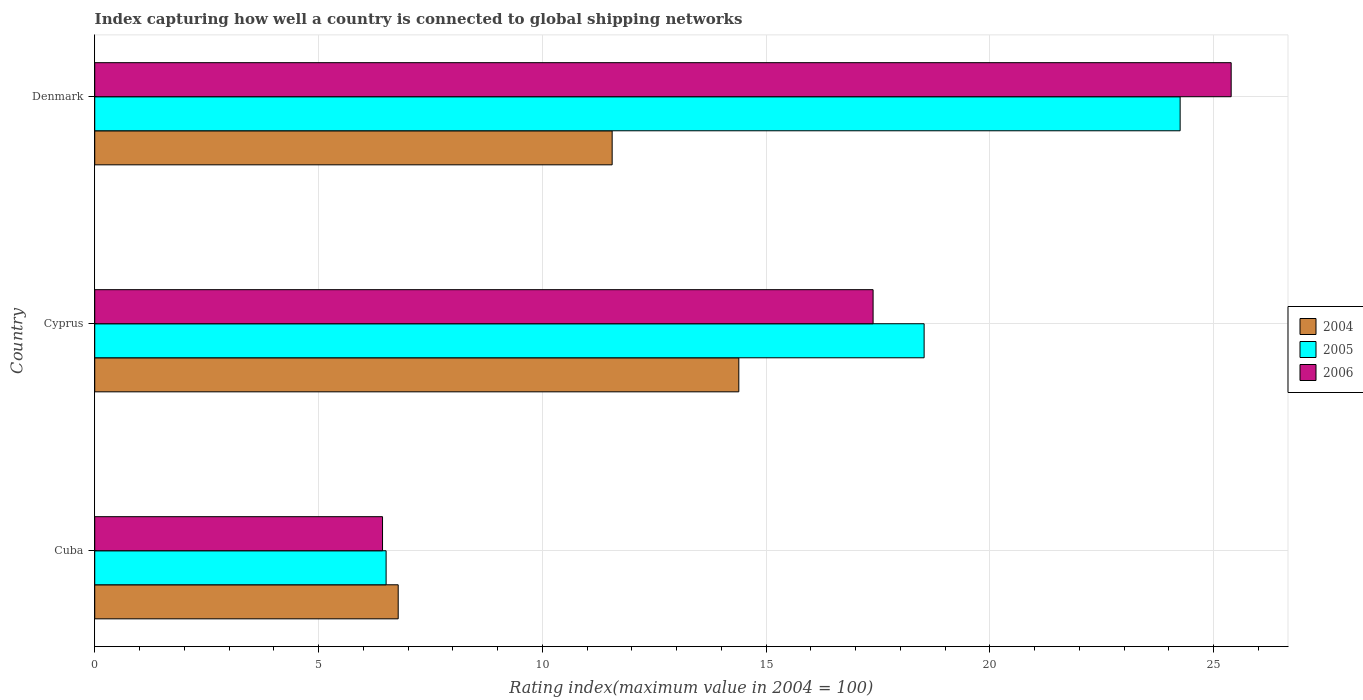Are the number of bars on each tick of the Y-axis equal?
Give a very brief answer. Yes. What is the label of the 3rd group of bars from the top?
Make the answer very short. Cuba. What is the rating index in 2006 in Cuba?
Provide a short and direct response. 6.43. Across all countries, what is the maximum rating index in 2004?
Offer a very short reply. 14.39. Across all countries, what is the minimum rating index in 2006?
Provide a succinct answer. 6.43. In which country was the rating index in 2004 maximum?
Make the answer very short. Cyprus. In which country was the rating index in 2005 minimum?
Offer a terse response. Cuba. What is the total rating index in 2004 in the graph?
Keep it short and to the point. 32.73. What is the difference between the rating index in 2005 in Cuba and that in Cyprus?
Offer a very short reply. -12.02. What is the difference between the rating index in 2006 in Cuba and the rating index in 2005 in Cyprus?
Offer a very short reply. -12.1. What is the average rating index in 2006 per country?
Keep it short and to the point. 16.4. What is the difference between the rating index in 2005 and rating index in 2006 in Denmark?
Ensure brevity in your answer.  -1.14. In how many countries, is the rating index in 2005 greater than 7 ?
Make the answer very short. 2. What is the ratio of the rating index in 2005 in Cuba to that in Cyprus?
Offer a very short reply. 0.35. What is the difference between the highest and the second highest rating index in 2006?
Your response must be concise. 8. What is the difference between the highest and the lowest rating index in 2006?
Provide a succinct answer. 18.96. Is the sum of the rating index in 2005 in Cyprus and Denmark greater than the maximum rating index in 2004 across all countries?
Your answer should be compact. Yes. Are all the bars in the graph horizontal?
Ensure brevity in your answer.  Yes. How many countries are there in the graph?
Keep it short and to the point. 3. Are the values on the major ticks of X-axis written in scientific E-notation?
Keep it short and to the point. No. Does the graph contain any zero values?
Your answer should be very brief. No. Does the graph contain grids?
Give a very brief answer. Yes. How are the legend labels stacked?
Provide a short and direct response. Vertical. What is the title of the graph?
Keep it short and to the point. Index capturing how well a country is connected to global shipping networks. What is the label or title of the X-axis?
Keep it short and to the point. Rating index(maximum value in 2004 = 100). What is the label or title of the Y-axis?
Provide a short and direct response. Country. What is the Rating index(maximum value in 2004 = 100) in 2004 in Cuba?
Ensure brevity in your answer.  6.78. What is the Rating index(maximum value in 2004 = 100) in 2005 in Cuba?
Provide a short and direct response. 6.51. What is the Rating index(maximum value in 2004 = 100) in 2006 in Cuba?
Offer a very short reply. 6.43. What is the Rating index(maximum value in 2004 = 100) of 2004 in Cyprus?
Your answer should be very brief. 14.39. What is the Rating index(maximum value in 2004 = 100) of 2005 in Cyprus?
Keep it short and to the point. 18.53. What is the Rating index(maximum value in 2004 = 100) in 2006 in Cyprus?
Your answer should be compact. 17.39. What is the Rating index(maximum value in 2004 = 100) of 2004 in Denmark?
Provide a short and direct response. 11.56. What is the Rating index(maximum value in 2004 = 100) of 2005 in Denmark?
Keep it short and to the point. 24.25. What is the Rating index(maximum value in 2004 = 100) in 2006 in Denmark?
Make the answer very short. 25.39. Across all countries, what is the maximum Rating index(maximum value in 2004 = 100) of 2004?
Offer a terse response. 14.39. Across all countries, what is the maximum Rating index(maximum value in 2004 = 100) in 2005?
Your answer should be compact. 24.25. Across all countries, what is the maximum Rating index(maximum value in 2004 = 100) of 2006?
Your answer should be compact. 25.39. Across all countries, what is the minimum Rating index(maximum value in 2004 = 100) in 2004?
Offer a very short reply. 6.78. Across all countries, what is the minimum Rating index(maximum value in 2004 = 100) in 2005?
Your response must be concise. 6.51. Across all countries, what is the minimum Rating index(maximum value in 2004 = 100) of 2006?
Your response must be concise. 6.43. What is the total Rating index(maximum value in 2004 = 100) of 2004 in the graph?
Provide a short and direct response. 32.73. What is the total Rating index(maximum value in 2004 = 100) in 2005 in the graph?
Keep it short and to the point. 49.29. What is the total Rating index(maximum value in 2004 = 100) in 2006 in the graph?
Your answer should be compact. 49.21. What is the difference between the Rating index(maximum value in 2004 = 100) in 2004 in Cuba and that in Cyprus?
Ensure brevity in your answer.  -7.61. What is the difference between the Rating index(maximum value in 2004 = 100) of 2005 in Cuba and that in Cyprus?
Offer a terse response. -12.02. What is the difference between the Rating index(maximum value in 2004 = 100) in 2006 in Cuba and that in Cyprus?
Your response must be concise. -10.96. What is the difference between the Rating index(maximum value in 2004 = 100) in 2004 in Cuba and that in Denmark?
Keep it short and to the point. -4.78. What is the difference between the Rating index(maximum value in 2004 = 100) in 2005 in Cuba and that in Denmark?
Your answer should be compact. -17.74. What is the difference between the Rating index(maximum value in 2004 = 100) in 2006 in Cuba and that in Denmark?
Your response must be concise. -18.96. What is the difference between the Rating index(maximum value in 2004 = 100) in 2004 in Cyprus and that in Denmark?
Your answer should be compact. 2.83. What is the difference between the Rating index(maximum value in 2004 = 100) of 2005 in Cyprus and that in Denmark?
Your answer should be very brief. -5.72. What is the difference between the Rating index(maximum value in 2004 = 100) in 2004 in Cuba and the Rating index(maximum value in 2004 = 100) in 2005 in Cyprus?
Offer a terse response. -11.75. What is the difference between the Rating index(maximum value in 2004 = 100) in 2004 in Cuba and the Rating index(maximum value in 2004 = 100) in 2006 in Cyprus?
Keep it short and to the point. -10.61. What is the difference between the Rating index(maximum value in 2004 = 100) in 2005 in Cuba and the Rating index(maximum value in 2004 = 100) in 2006 in Cyprus?
Your answer should be very brief. -10.88. What is the difference between the Rating index(maximum value in 2004 = 100) of 2004 in Cuba and the Rating index(maximum value in 2004 = 100) of 2005 in Denmark?
Provide a succinct answer. -17.47. What is the difference between the Rating index(maximum value in 2004 = 100) in 2004 in Cuba and the Rating index(maximum value in 2004 = 100) in 2006 in Denmark?
Offer a very short reply. -18.61. What is the difference between the Rating index(maximum value in 2004 = 100) in 2005 in Cuba and the Rating index(maximum value in 2004 = 100) in 2006 in Denmark?
Ensure brevity in your answer.  -18.88. What is the difference between the Rating index(maximum value in 2004 = 100) in 2004 in Cyprus and the Rating index(maximum value in 2004 = 100) in 2005 in Denmark?
Your answer should be compact. -9.86. What is the difference between the Rating index(maximum value in 2004 = 100) of 2004 in Cyprus and the Rating index(maximum value in 2004 = 100) of 2006 in Denmark?
Provide a succinct answer. -11. What is the difference between the Rating index(maximum value in 2004 = 100) in 2005 in Cyprus and the Rating index(maximum value in 2004 = 100) in 2006 in Denmark?
Your answer should be very brief. -6.86. What is the average Rating index(maximum value in 2004 = 100) in 2004 per country?
Keep it short and to the point. 10.91. What is the average Rating index(maximum value in 2004 = 100) in 2005 per country?
Keep it short and to the point. 16.43. What is the average Rating index(maximum value in 2004 = 100) of 2006 per country?
Your answer should be compact. 16.4. What is the difference between the Rating index(maximum value in 2004 = 100) of 2004 and Rating index(maximum value in 2004 = 100) of 2005 in Cuba?
Offer a terse response. 0.27. What is the difference between the Rating index(maximum value in 2004 = 100) in 2004 and Rating index(maximum value in 2004 = 100) in 2005 in Cyprus?
Your answer should be very brief. -4.14. What is the difference between the Rating index(maximum value in 2004 = 100) of 2004 and Rating index(maximum value in 2004 = 100) of 2006 in Cyprus?
Your answer should be very brief. -3. What is the difference between the Rating index(maximum value in 2004 = 100) of 2005 and Rating index(maximum value in 2004 = 100) of 2006 in Cyprus?
Your response must be concise. 1.14. What is the difference between the Rating index(maximum value in 2004 = 100) in 2004 and Rating index(maximum value in 2004 = 100) in 2005 in Denmark?
Provide a succinct answer. -12.69. What is the difference between the Rating index(maximum value in 2004 = 100) of 2004 and Rating index(maximum value in 2004 = 100) of 2006 in Denmark?
Your answer should be compact. -13.83. What is the difference between the Rating index(maximum value in 2004 = 100) in 2005 and Rating index(maximum value in 2004 = 100) in 2006 in Denmark?
Your answer should be compact. -1.14. What is the ratio of the Rating index(maximum value in 2004 = 100) in 2004 in Cuba to that in Cyprus?
Offer a terse response. 0.47. What is the ratio of the Rating index(maximum value in 2004 = 100) of 2005 in Cuba to that in Cyprus?
Keep it short and to the point. 0.35. What is the ratio of the Rating index(maximum value in 2004 = 100) of 2006 in Cuba to that in Cyprus?
Make the answer very short. 0.37. What is the ratio of the Rating index(maximum value in 2004 = 100) of 2004 in Cuba to that in Denmark?
Your answer should be compact. 0.59. What is the ratio of the Rating index(maximum value in 2004 = 100) of 2005 in Cuba to that in Denmark?
Your response must be concise. 0.27. What is the ratio of the Rating index(maximum value in 2004 = 100) in 2006 in Cuba to that in Denmark?
Keep it short and to the point. 0.25. What is the ratio of the Rating index(maximum value in 2004 = 100) in 2004 in Cyprus to that in Denmark?
Offer a terse response. 1.24. What is the ratio of the Rating index(maximum value in 2004 = 100) of 2005 in Cyprus to that in Denmark?
Offer a terse response. 0.76. What is the ratio of the Rating index(maximum value in 2004 = 100) of 2006 in Cyprus to that in Denmark?
Provide a short and direct response. 0.68. What is the difference between the highest and the second highest Rating index(maximum value in 2004 = 100) of 2004?
Provide a short and direct response. 2.83. What is the difference between the highest and the second highest Rating index(maximum value in 2004 = 100) in 2005?
Ensure brevity in your answer.  5.72. What is the difference between the highest and the second highest Rating index(maximum value in 2004 = 100) in 2006?
Your answer should be compact. 8. What is the difference between the highest and the lowest Rating index(maximum value in 2004 = 100) of 2004?
Offer a terse response. 7.61. What is the difference between the highest and the lowest Rating index(maximum value in 2004 = 100) in 2005?
Provide a short and direct response. 17.74. What is the difference between the highest and the lowest Rating index(maximum value in 2004 = 100) of 2006?
Keep it short and to the point. 18.96. 